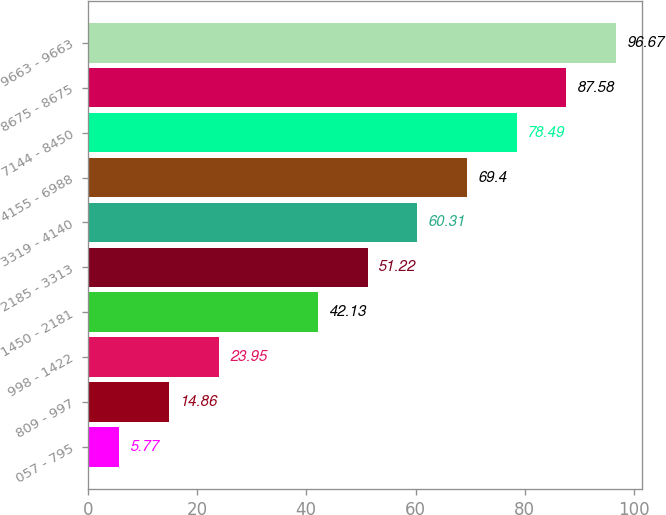Convert chart to OTSL. <chart><loc_0><loc_0><loc_500><loc_500><bar_chart><fcel>057 - 795<fcel>809 - 997<fcel>998 - 1422<fcel>1450 - 2181<fcel>2185 - 3313<fcel>3319 - 4140<fcel>4155 - 6988<fcel>7144 - 8450<fcel>8675 - 8675<fcel>9663 - 9663<nl><fcel>5.77<fcel>14.86<fcel>23.95<fcel>42.13<fcel>51.22<fcel>60.31<fcel>69.4<fcel>78.49<fcel>87.58<fcel>96.67<nl></chart> 